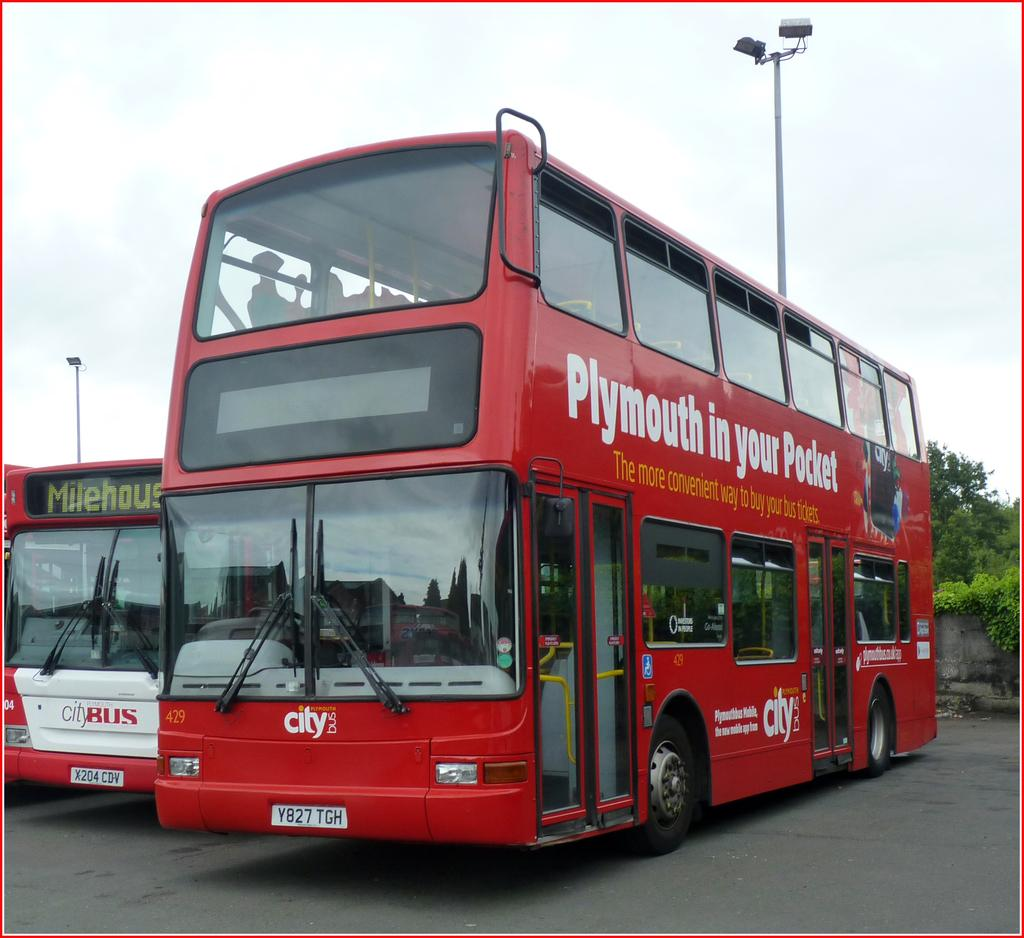What is the main subject in the center of the image? There is a bus in the center of the image. Are there any other buses visible in the image? Yes, there is another bus on the left side of the image. What type of vegetation can be seen on the right side of the image? There are plants on the right side of the image. What type of engine can be seen powering the buses in the image? There is no visible engine in the image, as the focus is on the buses themselves and not their internal components. 